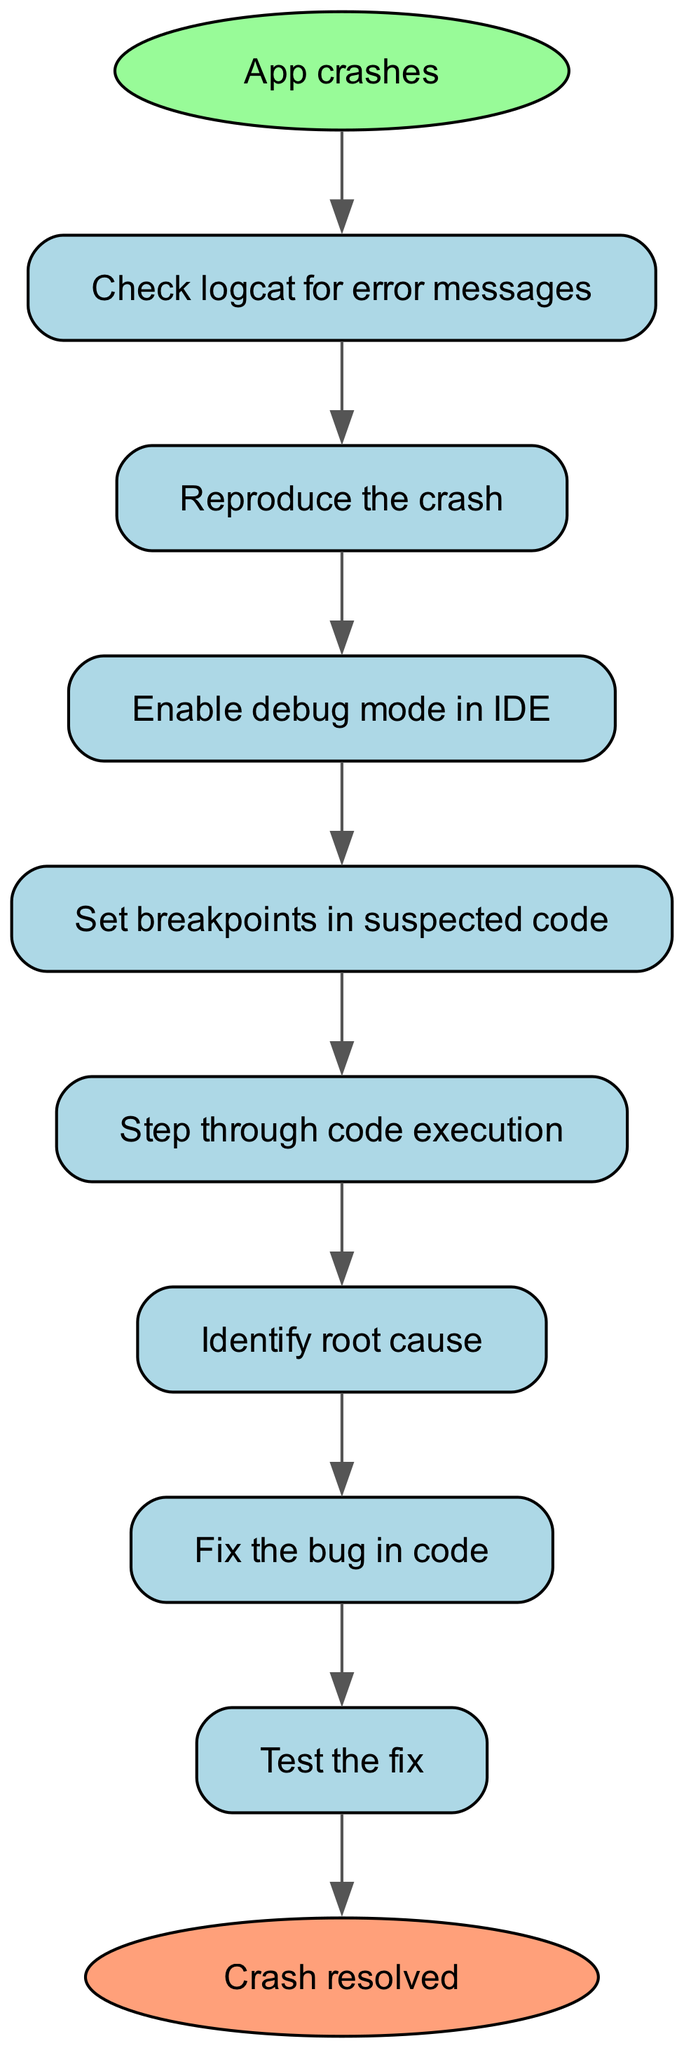What is the first step in the debugging workflow? The first step indicated in the diagram is the "App crashes" node, which initiates the workflow.
Answer: App crashes How many nodes are present in the diagram? A count of all nodes in the flow chart reveals there are ten unique nodes listed.
Answer: 10 What does the "Check logcat for error messages" node lead to? The "Check logcat for error messages" node has a direct edge leading to the "Reproduce the crash" node, indicating the next action after checking the logs.
Answer: Reproduce the crash Which node follows "Test the fix" in the process? The diagram indicates that after testing the fix, there is an endpoint, signified by the "Crash resolved" node, which concludes the workflow.
Answer: Crash resolved What action is taken after identifying the root cause? The next step following the "Identify root cause" node is the "Fix the bug in code" node, indicating a troubleshooting action is to be taken.
Answer: Fix the bug in code What is the relationship between the "Enable debug mode in IDE" and "Set breakpoints in suspected code"? The "Enable debug mode in IDE" node directly connects to the "Set breakpoints in suspected code" node, establishing a sequential continuing action in the debugging process.
Answer: Set breakpoints in suspected code What is the purpose of the "Step through code execution" node? The "Step through code execution" node serves to closely examine the code while it runs, allowing for real-time observation of the program's behavior to identify any discrepancies.
Answer: Identify root cause How many edges connect the nodes in the diagram? An analysis of the connections shows that there are nine edges that link all the operational steps together in the debugging workflow process.
Answer: 9 What indicates the end of the debugging workflow? The "Crash resolved" node, designed as an endpoint in the flow chart, signifies that the debugging process has been completed successfully.
Answer: Crash resolved 